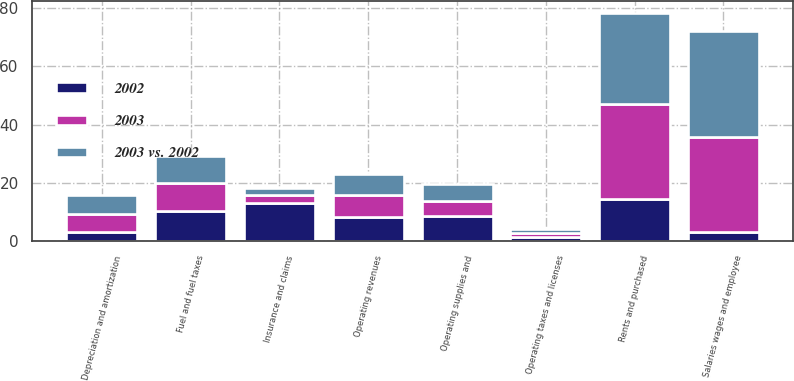<chart> <loc_0><loc_0><loc_500><loc_500><stacked_bar_chart><ecel><fcel>Operating revenues<fcel>Salaries wages and employee<fcel>Rents and purchased<fcel>Fuel and fuel taxes<fcel>Depreciation and amortization<fcel>Operating supplies and<fcel>Insurance and claims<fcel>Operating taxes and licenses<nl><fcel>2003<fcel>7.4<fcel>32.5<fcel>32.8<fcel>9.6<fcel>6.2<fcel>4.9<fcel>2.6<fcel>1.4<nl><fcel>2003 vs. 2002<fcel>7.4<fcel>36.4<fcel>31.1<fcel>9.4<fcel>6.5<fcel>5.8<fcel>2.5<fcel>1.4<nl><fcel>2002<fcel>8.3<fcel>3.2<fcel>14.4<fcel>10.3<fcel>3<fcel>8.8<fcel>13.1<fcel>1.3<nl></chart> 